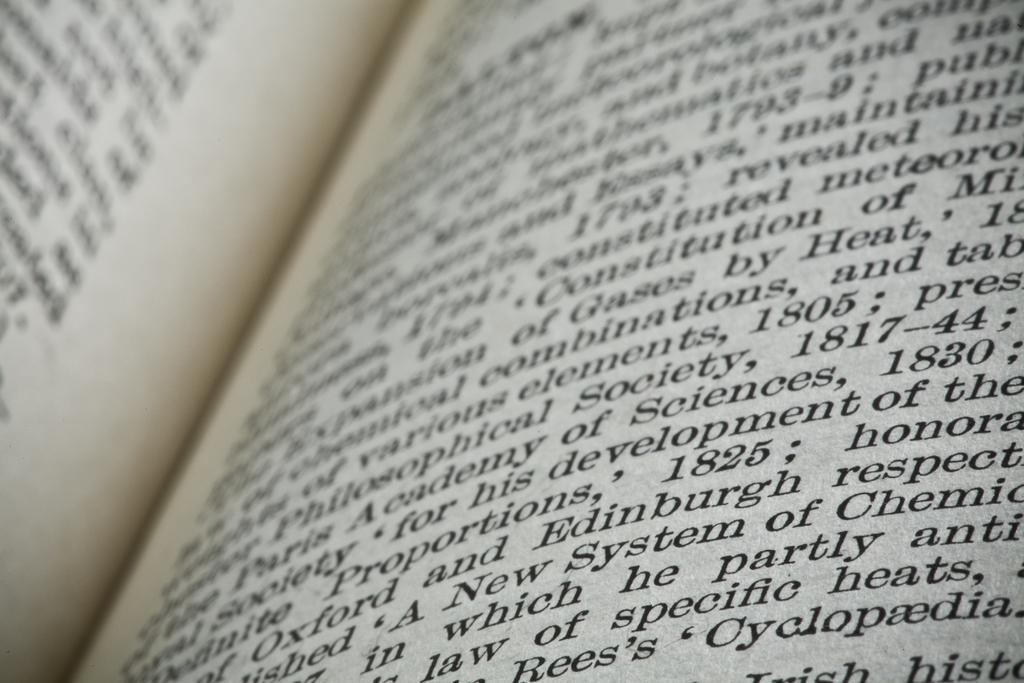<image>
Present a compact description of the photo's key features. An open book has the word Edinburgh and the date 1825 on the page. 